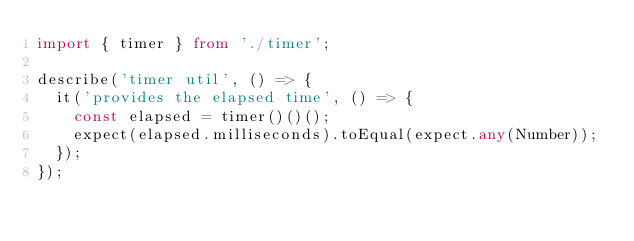<code> <loc_0><loc_0><loc_500><loc_500><_TypeScript_>import { timer } from './timer';

describe('timer util', () => {
  it('provides the elapsed time', () => {
    const elapsed = timer()()();
    expect(elapsed.milliseconds).toEqual(expect.any(Number));
  });
});
</code> 